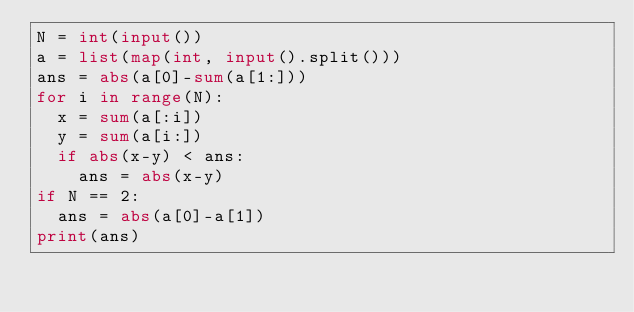<code> <loc_0><loc_0><loc_500><loc_500><_Python_>N = int(input())
a = list(map(int, input().split()))
ans = abs(a[0]-sum(a[1:]))
for i in range(N):
	x = sum(a[:i])
	y = sum(a[i:])
	if abs(x-y) < ans:
		ans = abs(x-y)
if N == 2:
	ans = abs(a[0]-a[1])
print(ans)
</code> 